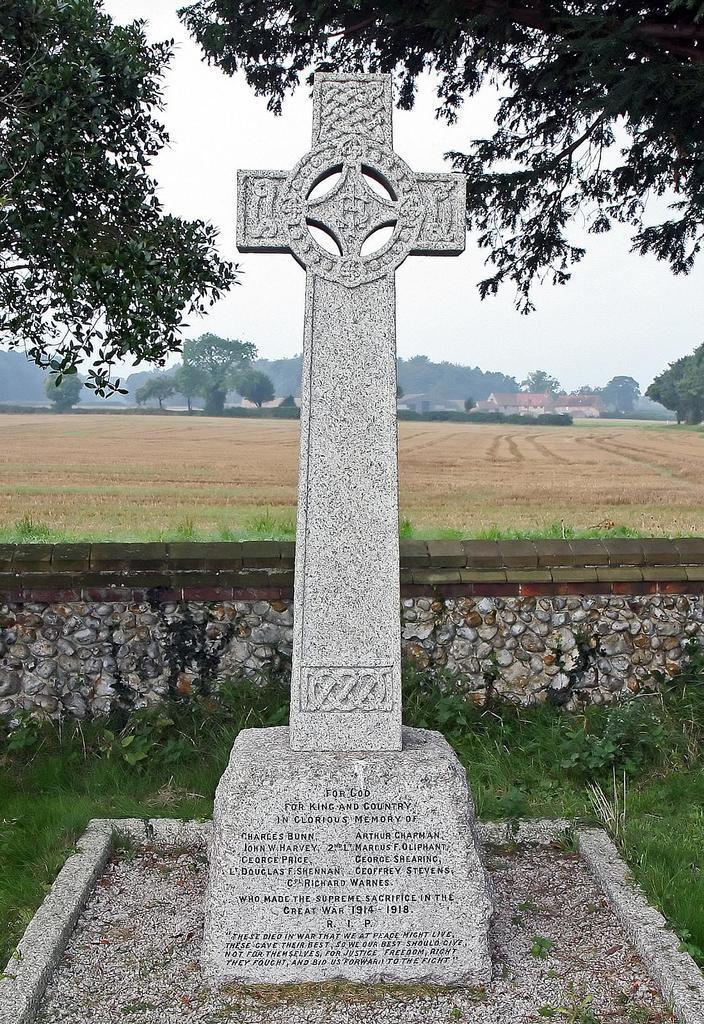Could you give a brief overview of what you see in this image? In this picture there is a sculpture in the foreground. At the back there are trees and buildings and there is a wall. At the top there is sky. At the bottom there is grass. 